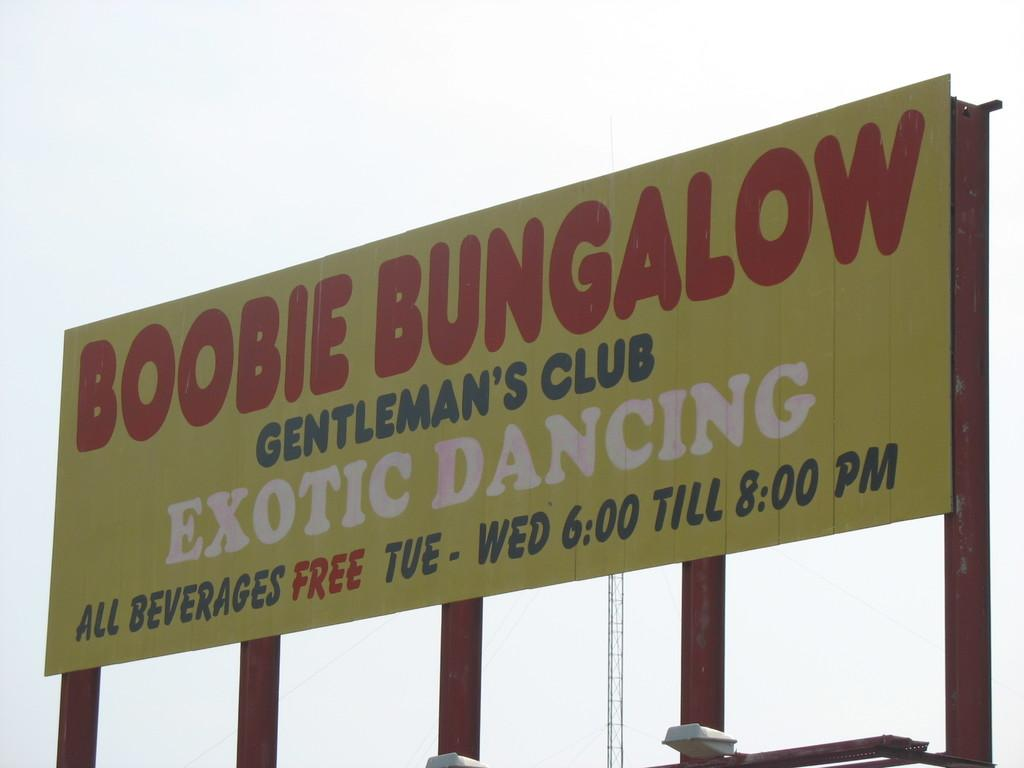<image>
Give a short and clear explanation of the subsequent image. A billboard advertising Boobie Bungalow Gentleman's Club with free drinks 